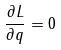Convert formula to latex. <formula><loc_0><loc_0><loc_500><loc_500>\frac { \partial L } { \partial q } = 0</formula> 